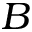<formula> <loc_0><loc_0><loc_500><loc_500>B</formula> 